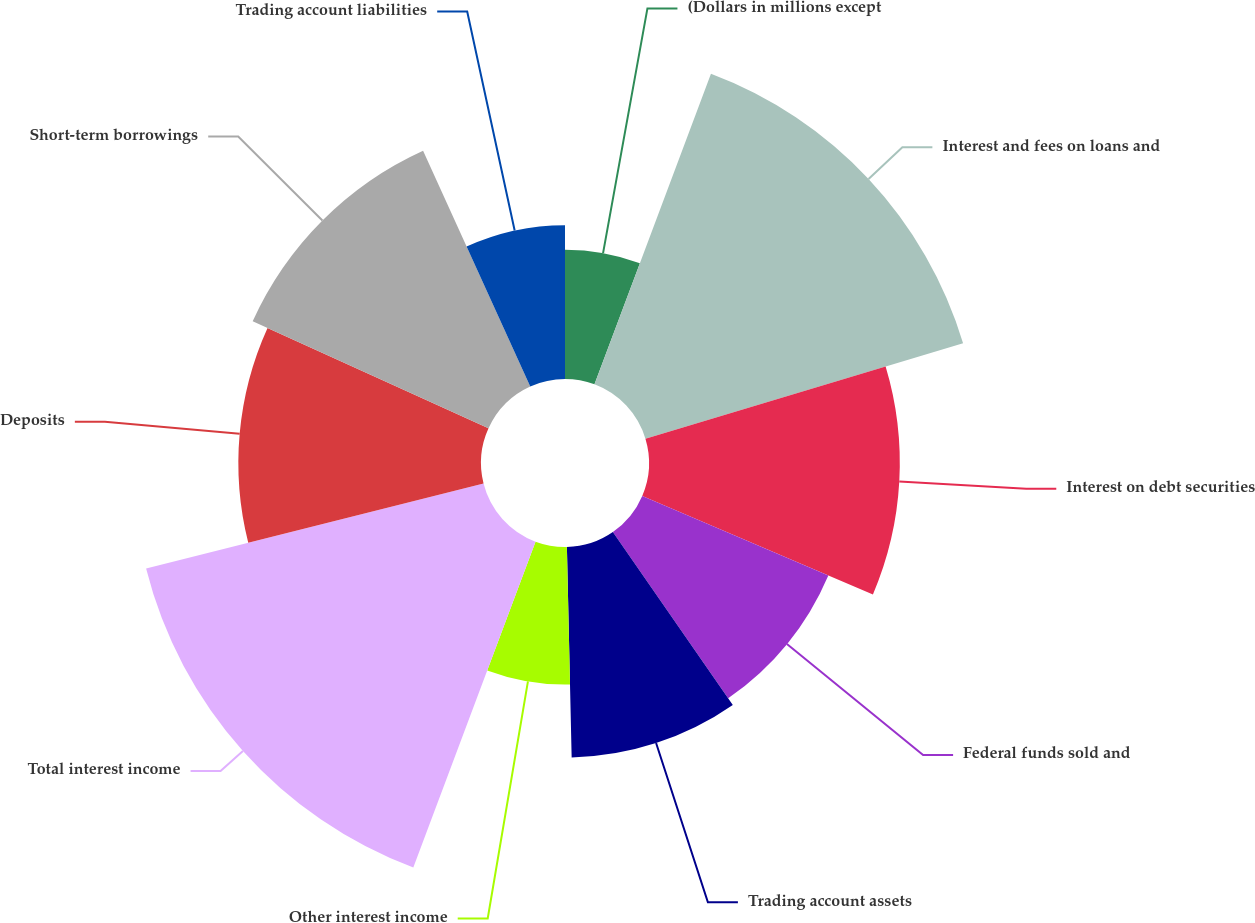Convert chart. <chart><loc_0><loc_0><loc_500><loc_500><pie_chart><fcel>(Dollars in millions except<fcel>Interest and fees on loans and<fcel>Interest on debt securities<fcel>Federal funds sold and<fcel>Trading account assets<fcel>Other interest income<fcel>Total interest income<fcel>Deposits<fcel>Short-term borrowings<fcel>Trading account liabilities<nl><fcel>5.71%<fcel>14.64%<fcel>11.07%<fcel>8.93%<fcel>9.29%<fcel>6.07%<fcel>15.36%<fcel>10.71%<fcel>11.43%<fcel>6.79%<nl></chart> 